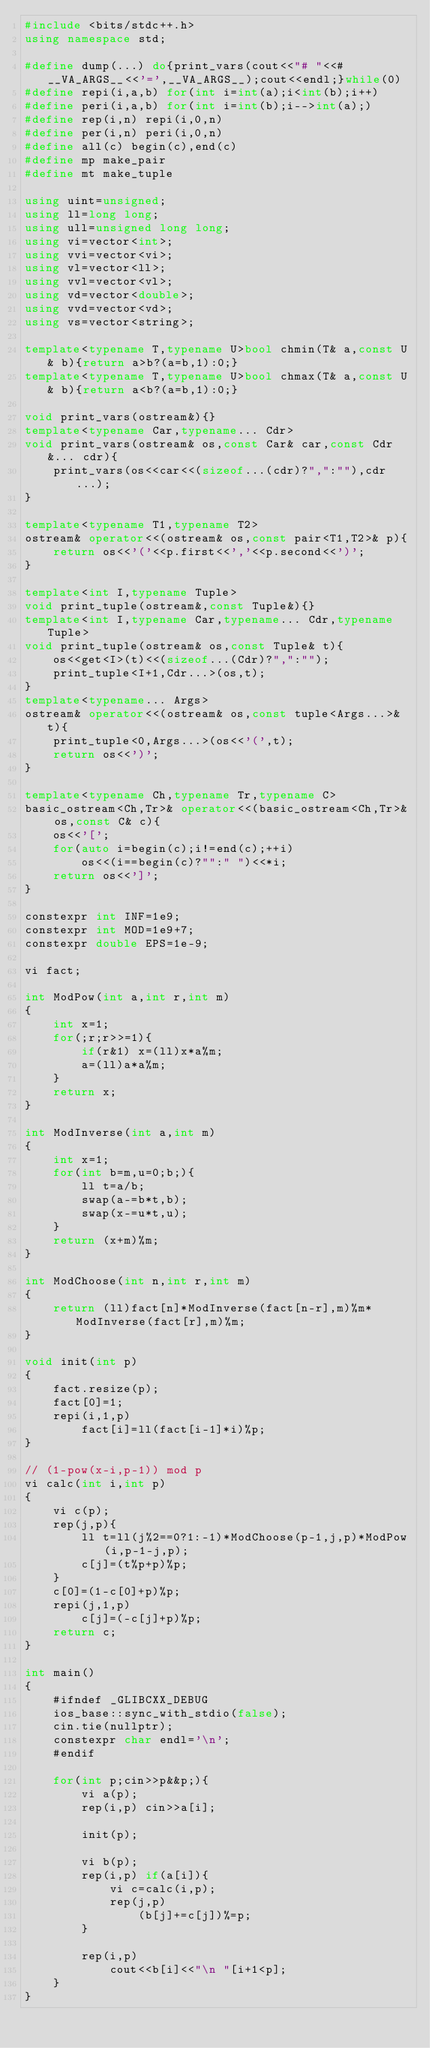Convert code to text. <code><loc_0><loc_0><loc_500><loc_500><_C++_>#include <bits/stdc++.h>
using namespace std;

#define dump(...) do{print_vars(cout<<"# "<<#__VA_ARGS__<<'=',__VA_ARGS__);cout<<endl;}while(0)
#define repi(i,a,b) for(int i=int(a);i<int(b);i++)
#define peri(i,a,b) for(int i=int(b);i-->int(a);)
#define rep(i,n) repi(i,0,n)
#define per(i,n) peri(i,0,n)
#define all(c) begin(c),end(c)
#define mp make_pair
#define mt make_tuple

using uint=unsigned;
using ll=long long;
using ull=unsigned long long;
using vi=vector<int>;
using vvi=vector<vi>;
using vl=vector<ll>;
using vvl=vector<vl>;
using vd=vector<double>;
using vvd=vector<vd>;
using vs=vector<string>;

template<typename T,typename U>bool chmin(T& a,const U& b){return a>b?(a=b,1):0;}
template<typename T,typename U>bool chmax(T& a,const U& b){return a<b?(a=b,1):0;}

void print_vars(ostream&){}
template<typename Car,typename... Cdr>
void print_vars(ostream& os,const Car& car,const Cdr&... cdr){
	print_vars(os<<car<<(sizeof...(cdr)?",":""),cdr...);
}

template<typename T1,typename T2>
ostream& operator<<(ostream& os,const pair<T1,T2>& p){
	return os<<'('<<p.first<<','<<p.second<<')';
}

template<int I,typename Tuple>
void print_tuple(ostream&,const Tuple&){}
template<int I,typename Car,typename... Cdr,typename Tuple>
void print_tuple(ostream& os,const Tuple& t){
	os<<get<I>(t)<<(sizeof...(Cdr)?",":"");
	print_tuple<I+1,Cdr...>(os,t);
}
template<typename... Args>
ostream& operator<<(ostream& os,const tuple<Args...>& t){
	print_tuple<0,Args...>(os<<'(',t);
	return os<<')';
}

template<typename Ch,typename Tr,typename C>
basic_ostream<Ch,Tr>& operator<<(basic_ostream<Ch,Tr>& os,const C& c){
	os<<'[';
	for(auto i=begin(c);i!=end(c);++i)
		os<<(i==begin(c)?"":" ")<<*i;
	return os<<']';
}

constexpr int INF=1e9;
constexpr int MOD=1e9+7;
constexpr double EPS=1e-9;

vi fact;

int ModPow(int a,int r,int m)
{
	int x=1;
	for(;r;r>>=1){
		if(r&1) x=(ll)x*a%m;
		a=(ll)a*a%m;
	}
	return x;
}

int ModInverse(int a,int m)
{
	int x=1;
	for(int b=m,u=0;b;){
		ll t=a/b;
		swap(a-=b*t,b);
		swap(x-=u*t,u);
	}
	return (x+m)%m;
}

int ModChoose(int n,int r,int m)
{
	return (ll)fact[n]*ModInverse(fact[n-r],m)%m*ModInverse(fact[r],m)%m;
}

void init(int p)
{
	fact.resize(p);
	fact[0]=1;
	repi(i,1,p)
		fact[i]=ll(fact[i-1]*i)%p;
}

// (1-pow(x-i,p-1)) mod p
vi calc(int i,int p)
{
	vi c(p);
	rep(j,p){
		ll t=ll(j%2==0?1:-1)*ModChoose(p-1,j,p)*ModPow(i,p-1-j,p);
		c[j]=(t%p+p)%p;
	}
	c[0]=(1-c[0]+p)%p;
	repi(j,1,p)
		c[j]=(-c[j]+p)%p;
	return c;
}

int main()
{
	#ifndef _GLIBCXX_DEBUG
	ios_base::sync_with_stdio(false);
	cin.tie(nullptr);
	constexpr char endl='\n';
	#endif

	for(int p;cin>>p&&p;){
		vi a(p);
		rep(i,p) cin>>a[i];

		init(p);

		vi b(p);
		rep(i,p) if(a[i]){
			vi c=calc(i,p);
			rep(j,p)
				(b[j]+=c[j])%=p;
		}

		rep(i,p)
			cout<<b[i]<<"\n "[i+1<p];
	}
}
</code> 